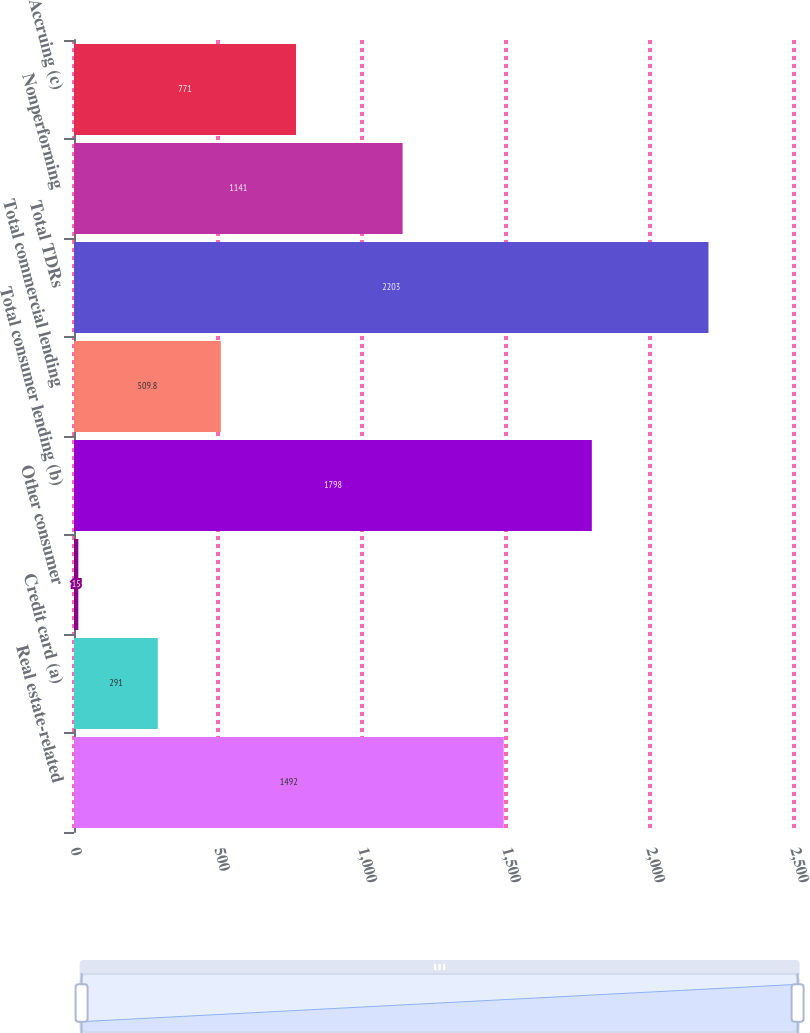<chart> <loc_0><loc_0><loc_500><loc_500><bar_chart><fcel>Real estate-related<fcel>Credit card (a)<fcel>Other consumer<fcel>Total consumer lending (b)<fcel>Total commercial lending<fcel>Total TDRs<fcel>Nonperforming<fcel>Accruing (c)<nl><fcel>1492<fcel>291<fcel>15<fcel>1798<fcel>509.8<fcel>2203<fcel>1141<fcel>771<nl></chart> 